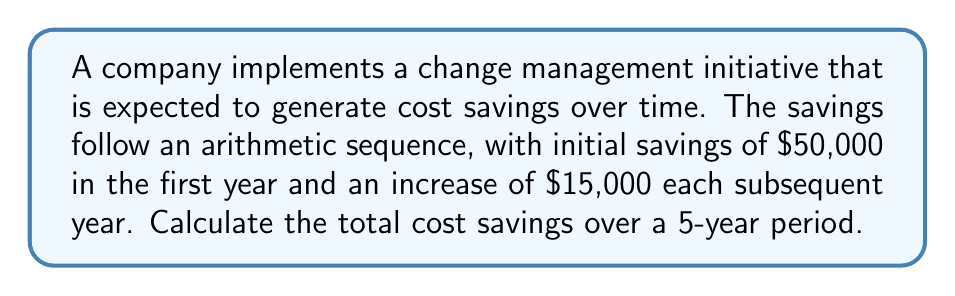Teach me how to tackle this problem. Let's approach this step-by-step using the arithmetic sequence formula:

1) The arithmetic sequence is defined by:
   $a_n = a_1 + (n-1)d$
   Where $a_n$ is the nth term, $a_1$ is the first term, $n$ is the term number, and $d$ is the common difference.

2) We're given:
   $a_1 = 50,000$ (initial savings)
   $d = 15,000$ (yearly increase)
   $n = 5$ (5-year period)

3) The savings for each year are:
   Year 1: $a_1 = 50,000$
   Year 2: $a_2 = 50,000 + 15,000 = 65,000$
   Year 3: $a_3 = 50,000 + 2(15,000) = 80,000$
   Year 4: $a_4 = 50,000 + 3(15,000) = 95,000$
   Year 5: $a_5 = 50,000 + 4(15,000) = 110,000$

4) To find the total savings, we need to sum these values. We can use the arithmetic sequence sum formula:

   $S_n = \frac{n}{2}(a_1 + a_n)$

   Where $S_n$ is the sum of $n$ terms, $a_1$ is the first term, and $a_n$ is the last term.

5) Substituting our values:
   $S_5 = \frac{5}{2}(50,000 + 110,000)$
   $S_5 = \frac{5}{2}(160,000)$
   $S_5 = 5 * 80,000 = 400,000$

Therefore, the total cost savings over the 5-year period is $400,000.
Answer: $400,000 